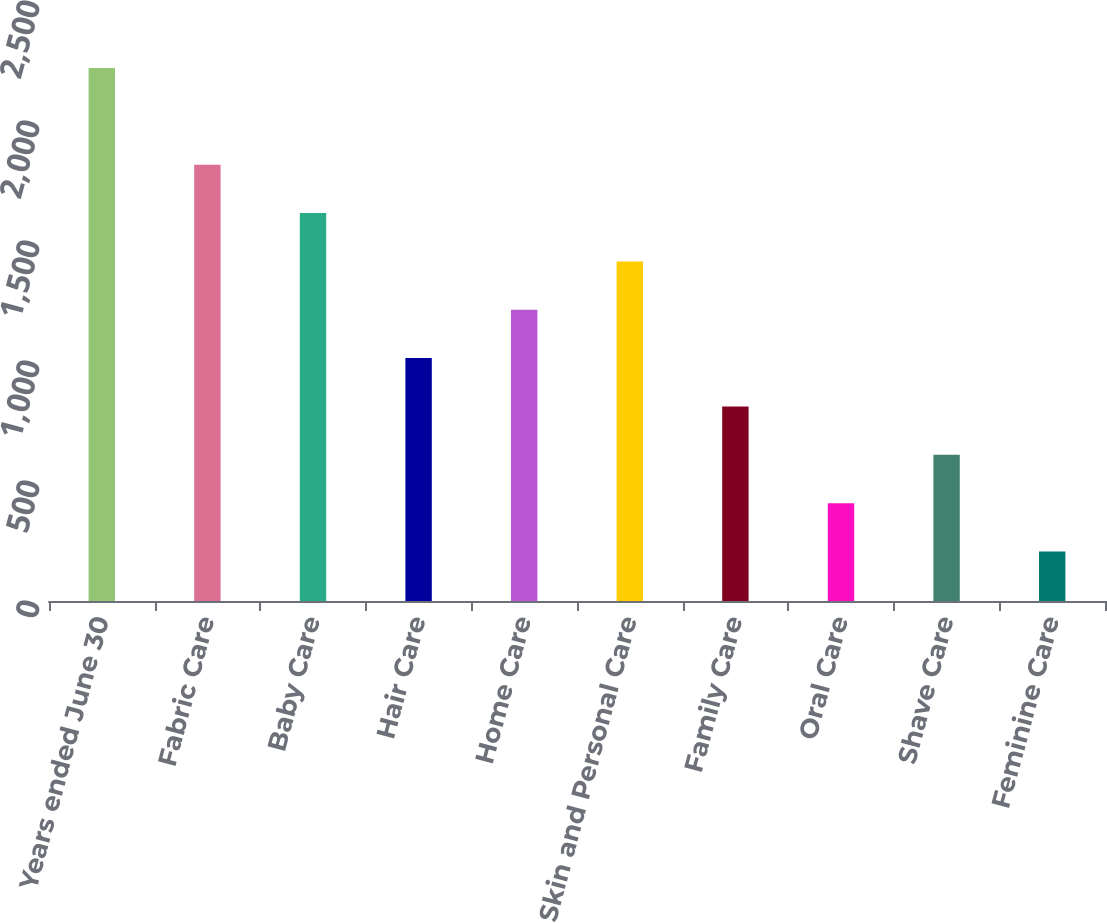Convert chart. <chart><loc_0><loc_0><loc_500><loc_500><bar_chart><fcel>Years ended June 30<fcel>Fabric Care<fcel>Baby Care<fcel>Hair Care<fcel>Home Care<fcel>Skin and Personal Care<fcel>Family Care<fcel>Oral Care<fcel>Shave Care<fcel>Feminine Care<nl><fcel>2220.4<fcel>1817.6<fcel>1616.2<fcel>1012<fcel>1213.4<fcel>1414.8<fcel>810.6<fcel>407.8<fcel>609.2<fcel>206.4<nl></chart> 